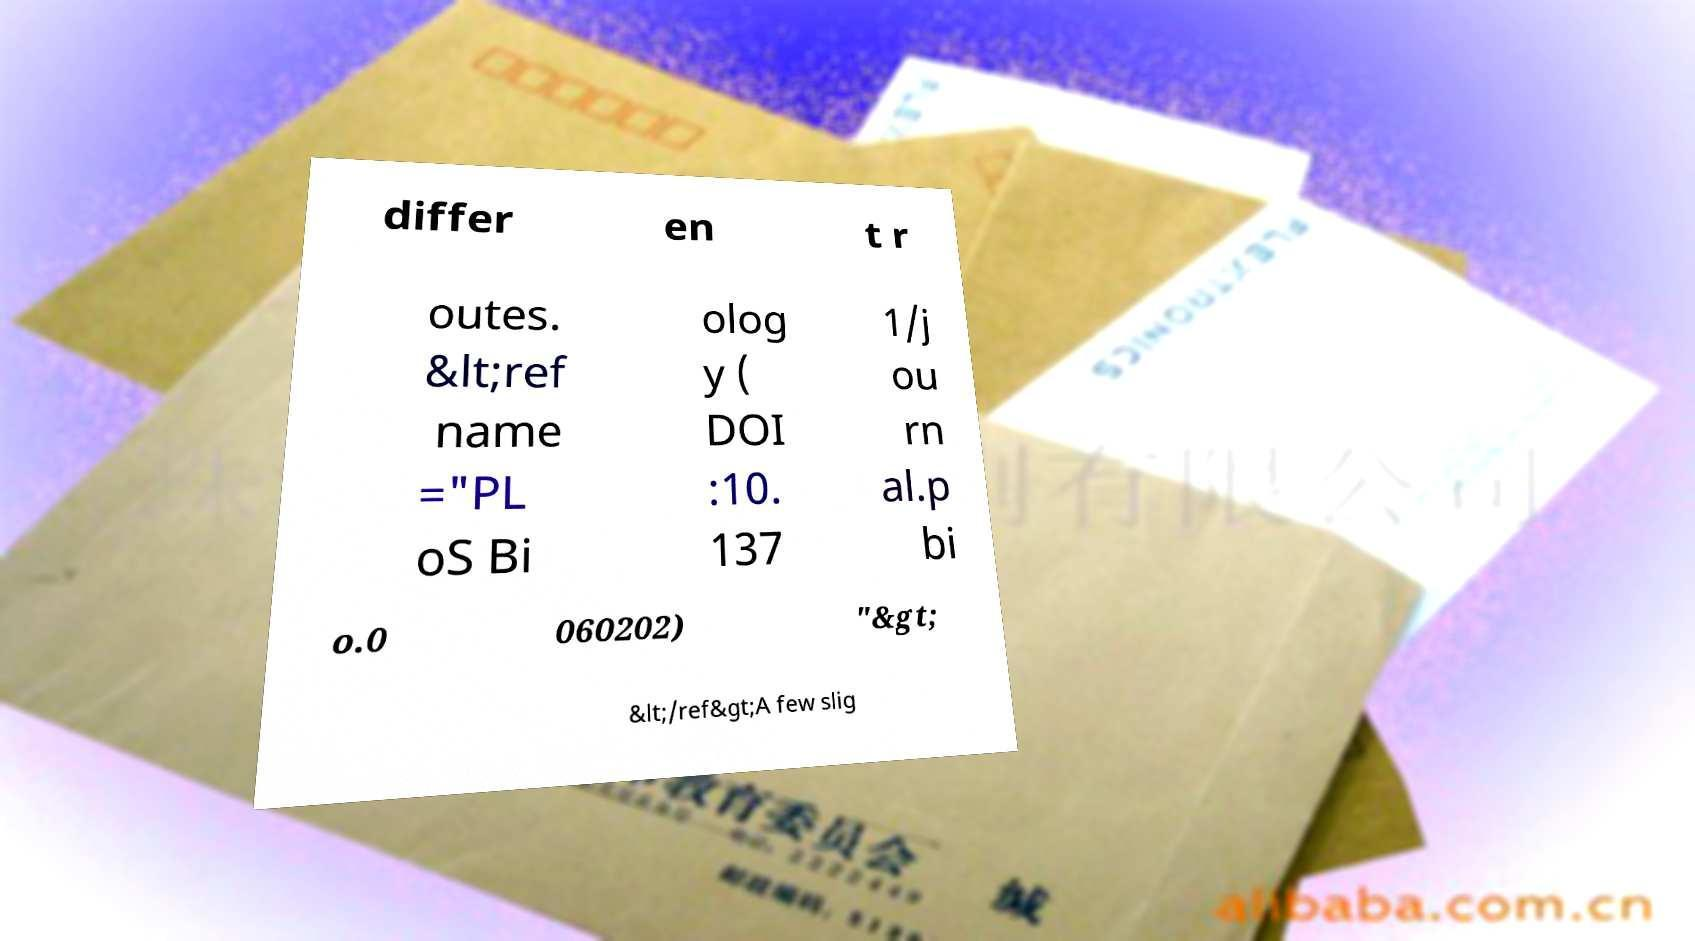Could you assist in decoding the text presented in this image and type it out clearly? differ en t r outes. &lt;ref name ="PL oS Bi olog y ( DOI :10. 137 1/j ou rn al.p bi o.0 060202) "&gt; &lt;/ref&gt;A few slig 